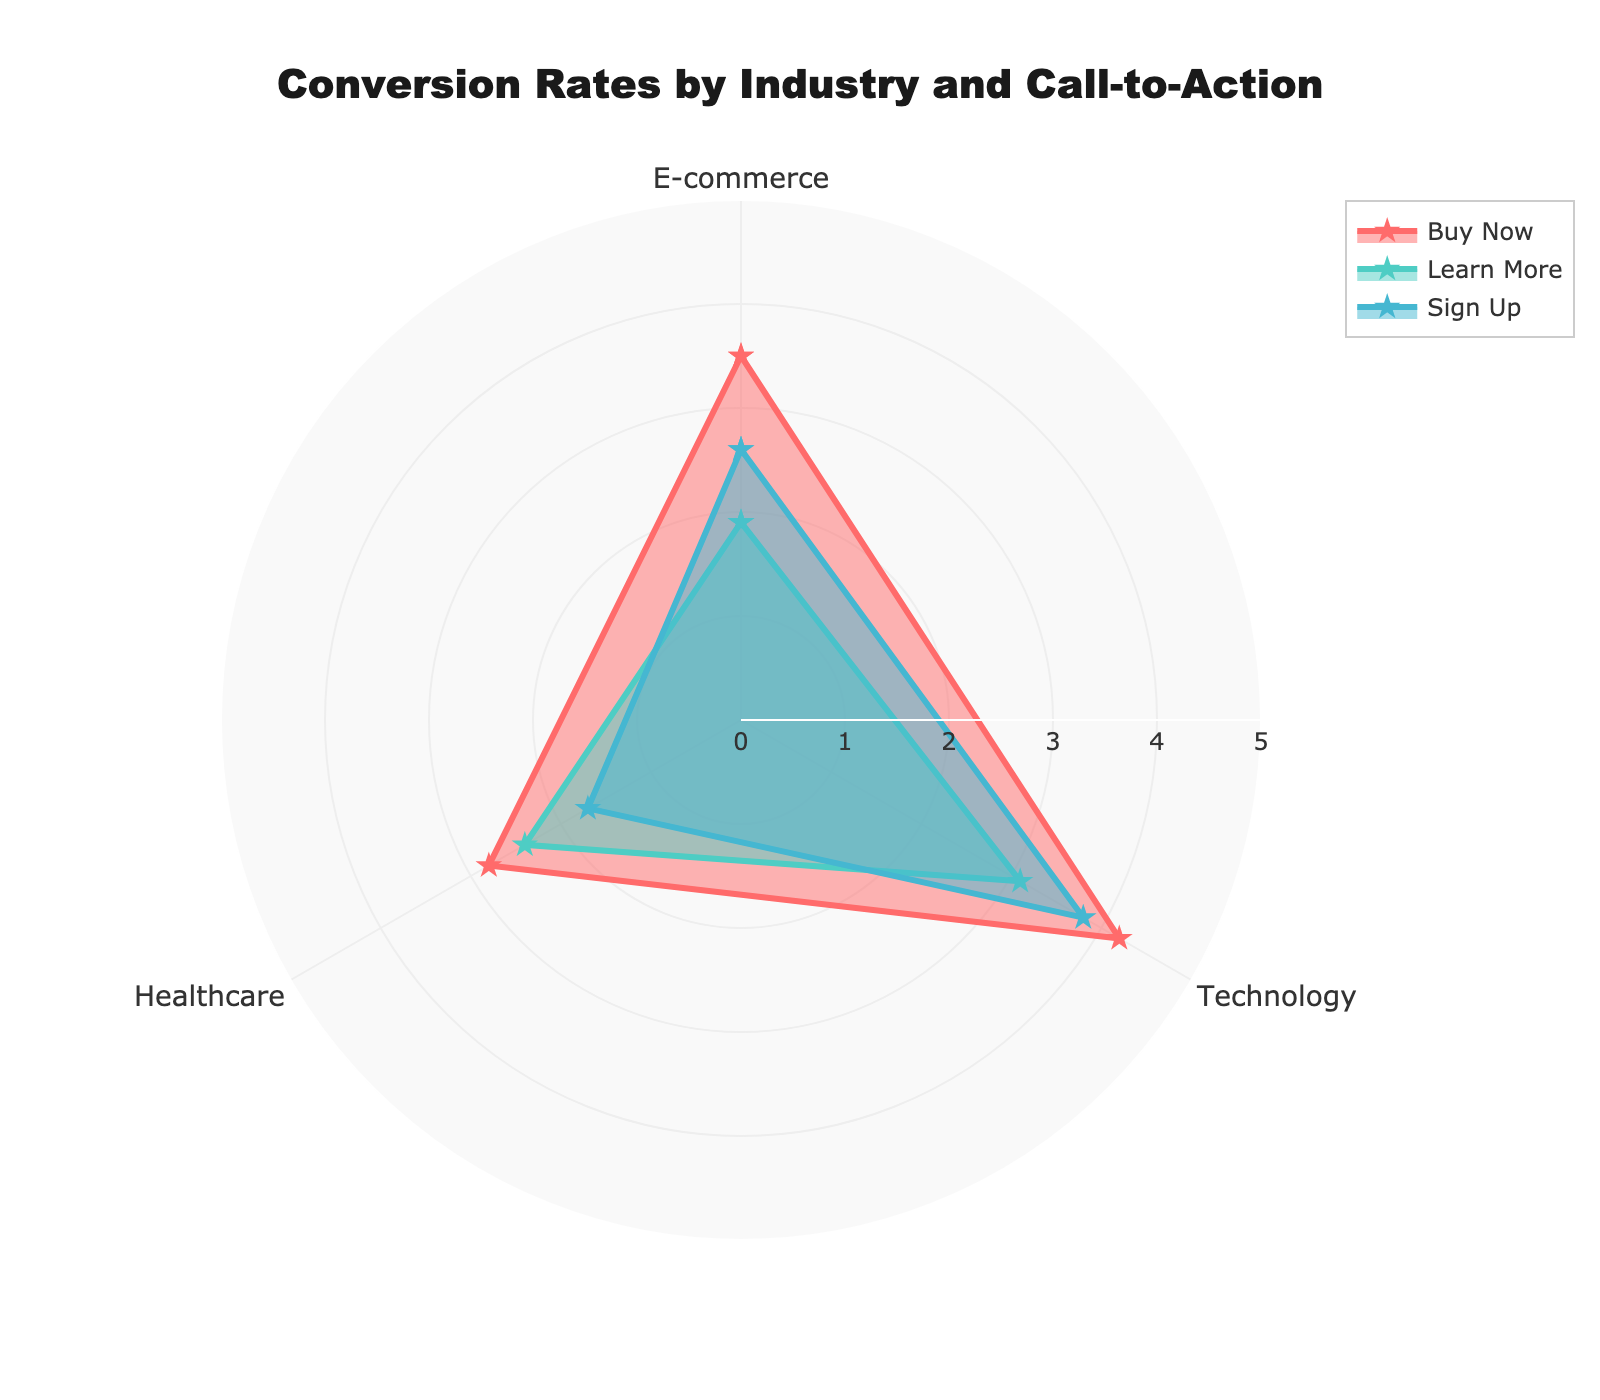What is the overall title of the radar chart? The title of the chart is displayed prominently at the top. It states: "Conversion Rates by Industry and Call-to-Action."
Answer: Conversion Rates by Industry and Call-to-Action Which Call-to-Action phrase has the highest conversion rate in the Technology industry? By looking at the radar chart, compare the points across different Call-to-Action phrases for the Technology industry. The point for "Buy Now" has the highest value, which is 4.2.
Answer: Buy Now What is the average conversion rate for 'Sign Up' across all industries? To find the average, sum the conversion rates for 'Sign Up' across all industries and divide by the number of industries: (2.6 + 3.8 + 1.7) = 8.1, then 8.1 / 3 = 2.7
Answer: 2.7 Which industry has the lowest conversion rate for 'Learn More'? Look at the points for 'Learn More' across all industries and identify the smallest value. The Healthcare industry's point is the lowest at 2.4.
Answer: Healthcare What is the difference in conversion rates for 'Buy Now' between the E-commerce and Healthcare industries? Subtract the conversion rate for 'Buy Now' in Healthcare from that in E-commerce: 3.5 - 2.8 = 0.7
Answer: 0.7 Which Call-to-Action phrase has the most consistent conversion rates across all industries? By observing the radar chart, 'Buy Now' has conversion rates of 3.5, 4.2, and 2.8, 'Learn More' has 1.9, 3.1, and 2.4, whereas 'Sign Up' has 2.6, 3.8, and 1.7. Therefore, 'Buy Now' has the least variation.
Answer: Buy Now How many different industries are displayed on the radar chart? Each unique category on the radar chart represents an industry. The chart shows three distinct industries: E-commerce, Technology, and Healthcare.
Answer: 3 Which Call-to-Action phrase shows the highest variability in its conversion rates across industries? Variability can be seen by observing the spread of the data points. 'Sign Up' shows the highest variability with values 2.6, 3.8, and 1.7 across the E-commerce, Technology, and Healthcare industries respectively.
Answer: Sign Up 